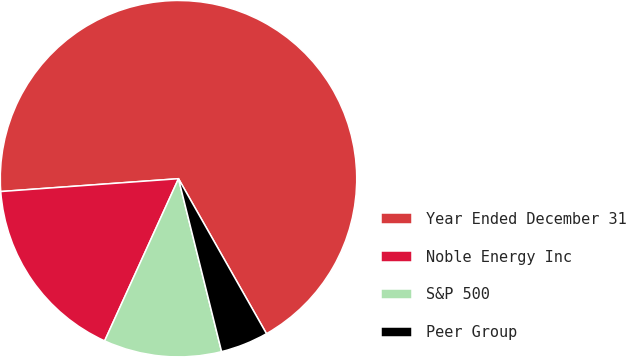<chart> <loc_0><loc_0><loc_500><loc_500><pie_chart><fcel>Year Ended December 31<fcel>Noble Energy Inc<fcel>S&P 500<fcel>Peer Group<nl><fcel>67.93%<fcel>17.05%<fcel>10.69%<fcel>4.33%<nl></chart> 